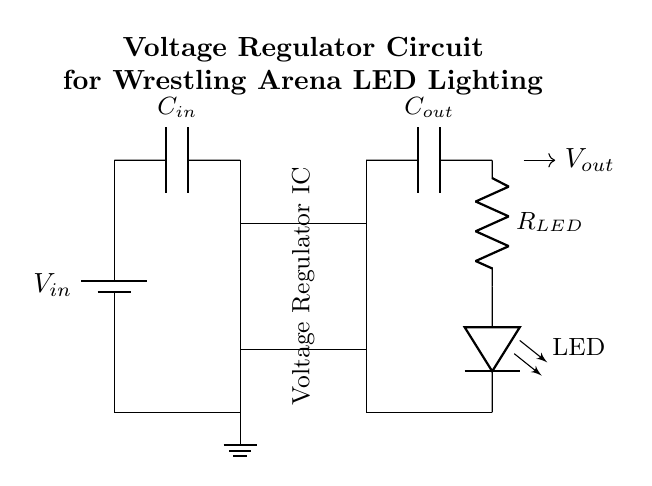What is the input voltage symbol in the circuit? The symbol for the input voltage in the circuit is represented as \( V_{in} \), which is shown next to the battery symbol.
Answer: \( V_{in} \) What type of component is the device labeled as a "Voltage Regulator IC"? The device is classified as an integrated circuit, specifically designed to regulate voltage levels within the circuit.
Answer: Integrated circuit What is the function of capacitor \( C_{in} \)? Capacitor \( C_{in} \) is used to stabilize the input voltage by filtering out noise and providing a smooth supply to the voltage regulator, ensuring consistent performance.
Answer: Stabilization How many capacitors are in this circuit? There are two capacitors identified in the circuit diagram, \( C_{in} \) and \( C_{out} \), which are used for input and output stabilization respectively.
Answer: Two What is the purpose of the resistor \( R_{LED} \) in this circuit? The resistor \( R_{LED} \) limits the current flowing through the LED to prevent it from burning out, ensuring that it operates within safe current levels.
Answer: Current limiting How does the output voltage \( V_{out} \) depend on the input voltage? The output voltage \( V_{out} \) is regulated by the voltage regulator IC, which steps down and stabilizes the input voltage \( V_{in} \) to a lower, constant level suitable for the LED.
Answer: Regulated Which component ensures that the LED lights up? The LED component in the circuit diagram is the primary light-emitting element that illuminates when powered by a suitable output voltage.
Answer: LED 